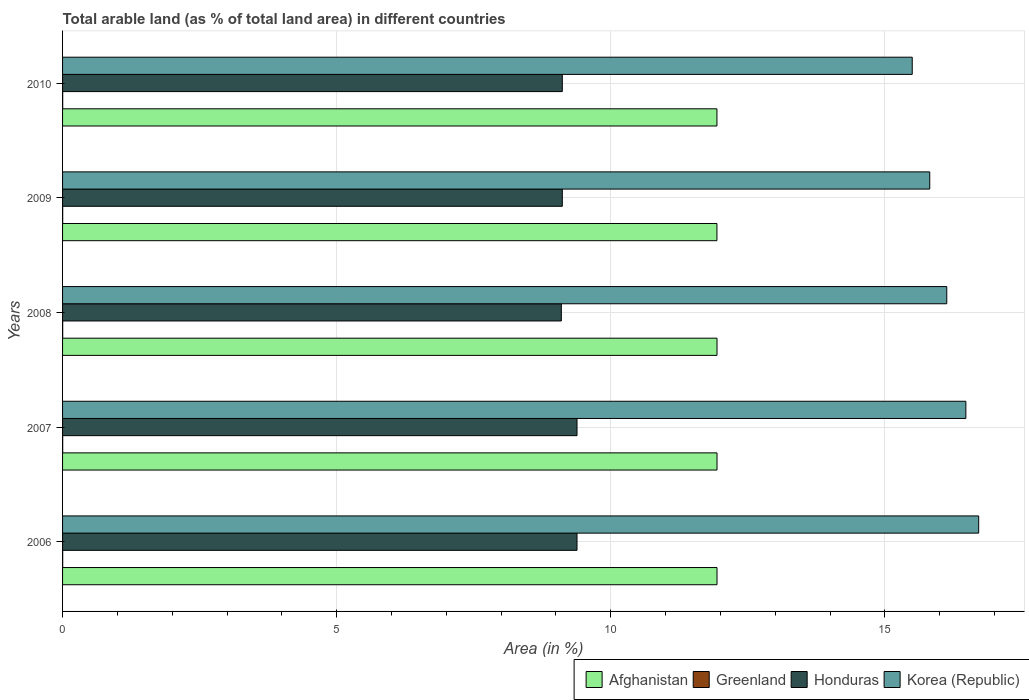How many groups of bars are there?
Give a very brief answer. 5. Are the number of bars on each tick of the Y-axis equal?
Make the answer very short. Yes. How many bars are there on the 2nd tick from the top?
Provide a succinct answer. 4. How many bars are there on the 5th tick from the bottom?
Make the answer very short. 4. What is the label of the 4th group of bars from the top?
Your answer should be compact. 2007. What is the percentage of arable land in Honduras in 2008?
Your answer should be compact. 9.1. Across all years, what is the maximum percentage of arable land in Korea (Republic)?
Make the answer very short. 16.71. Across all years, what is the minimum percentage of arable land in Korea (Republic)?
Ensure brevity in your answer.  15.5. In which year was the percentage of arable land in Honduras minimum?
Ensure brevity in your answer.  2008. What is the total percentage of arable land in Greenland in the graph?
Keep it short and to the point. 0.01. What is the difference between the percentage of arable land in Greenland in 2006 and that in 2007?
Provide a short and direct response. 0. What is the difference between the percentage of arable land in Korea (Republic) in 2006 and the percentage of arable land in Honduras in 2010?
Provide a short and direct response. 7.6. What is the average percentage of arable land in Korea (Republic) per year?
Provide a succinct answer. 16.13. In the year 2008, what is the difference between the percentage of arable land in Honduras and percentage of arable land in Afghanistan?
Your answer should be compact. -2.84. What is the ratio of the percentage of arable land in Korea (Republic) in 2006 to that in 2008?
Make the answer very short. 1.04. Is the percentage of arable land in Korea (Republic) in 2008 less than that in 2010?
Ensure brevity in your answer.  No. What is the difference between the highest and the lowest percentage of arable land in Greenland?
Offer a terse response. 0. Is it the case that in every year, the sum of the percentage of arable land in Afghanistan and percentage of arable land in Greenland is greater than the sum of percentage of arable land in Korea (Republic) and percentage of arable land in Honduras?
Give a very brief answer. No. What does the 3rd bar from the top in 2010 represents?
Give a very brief answer. Greenland. How many bars are there?
Keep it short and to the point. 20. Are all the bars in the graph horizontal?
Ensure brevity in your answer.  Yes. How many years are there in the graph?
Provide a short and direct response. 5. Where does the legend appear in the graph?
Your answer should be very brief. Bottom right. How many legend labels are there?
Your answer should be very brief. 4. What is the title of the graph?
Give a very brief answer. Total arable land (as % of total land area) in different countries. Does "Fiji" appear as one of the legend labels in the graph?
Provide a succinct answer. No. What is the label or title of the X-axis?
Give a very brief answer. Area (in %). What is the Area (in %) of Afghanistan in 2006?
Your response must be concise. 11.94. What is the Area (in %) of Greenland in 2006?
Your response must be concise. 0. What is the Area (in %) of Honduras in 2006?
Keep it short and to the point. 9.38. What is the Area (in %) in Korea (Republic) in 2006?
Give a very brief answer. 16.71. What is the Area (in %) of Afghanistan in 2007?
Your answer should be very brief. 11.94. What is the Area (in %) of Greenland in 2007?
Keep it short and to the point. 0. What is the Area (in %) of Honduras in 2007?
Keep it short and to the point. 9.38. What is the Area (in %) of Korea (Republic) in 2007?
Your answer should be very brief. 16.48. What is the Area (in %) in Afghanistan in 2008?
Your answer should be very brief. 11.94. What is the Area (in %) of Greenland in 2008?
Provide a short and direct response. 0. What is the Area (in %) in Honduras in 2008?
Keep it short and to the point. 9.1. What is the Area (in %) in Korea (Republic) in 2008?
Give a very brief answer. 16.13. What is the Area (in %) in Afghanistan in 2009?
Your response must be concise. 11.94. What is the Area (in %) in Greenland in 2009?
Provide a short and direct response. 0. What is the Area (in %) in Honduras in 2009?
Make the answer very short. 9.12. What is the Area (in %) of Korea (Republic) in 2009?
Provide a succinct answer. 15.82. What is the Area (in %) of Afghanistan in 2010?
Provide a succinct answer. 11.94. What is the Area (in %) of Greenland in 2010?
Your response must be concise. 0. What is the Area (in %) of Honduras in 2010?
Make the answer very short. 9.12. What is the Area (in %) in Korea (Republic) in 2010?
Keep it short and to the point. 15.5. Across all years, what is the maximum Area (in %) of Afghanistan?
Keep it short and to the point. 11.94. Across all years, what is the maximum Area (in %) in Greenland?
Give a very brief answer. 0. Across all years, what is the maximum Area (in %) of Honduras?
Make the answer very short. 9.38. Across all years, what is the maximum Area (in %) of Korea (Republic)?
Ensure brevity in your answer.  16.71. Across all years, what is the minimum Area (in %) of Afghanistan?
Ensure brevity in your answer.  11.94. Across all years, what is the minimum Area (in %) in Greenland?
Give a very brief answer. 0. Across all years, what is the minimum Area (in %) of Honduras?
Your answer should be very brief. 9.1. Across all years, what is the minimum Area (in %) of Korea (Republic)?
Your response must be concise. 15.5. What is the total Area (in %) of Afghanistan in the graph?
Offer a very short reply. 59.69. What is the total Area (in %) of Greenland in the graph?
Offer a terse response. 0.01. What is the total Area (in %) of Honduras in the graph?
Provide a short and direct response. 46.1. What is the total Area (in %) in Korea (Republic) in the graph?
Keep it short and to the point. 80.64. What is the difference between the Area (in %) of Greenland in 2006 and that in 2007?
Offer a terse response. 0. What is the difference between the Area (in %) of Korea (Republic) in 2006 and that in 2007?
Offer a very short reply. 0.23. What is the difference between the Area (in %) in Afghanistan in 2006 and that in 2008?
Your answer should be very brief. 0. What is the difference between the Area (in %) of Honduras in 2006 and that in 2008?
Make the answer very short. 0.29. What is the difference between the Area (in %) in Korea (Republic) in 2006 and that in 2008?
Offer a very short reply. 0.58. What is the difference between the Area (in %) of Afghanistan in 2006 and that in 2009?
Your answer should be compact. 0. What is the difference between the Area (in %) of Greenland in 2006 and that in 2009?
Your answer should be compact. 0. What is the difference between the Area (in %) in Honduras in 2006 and that in 2009?
Ensure brevity in your answer.  0.27. What is the difference between the Area (in %) of Korea (Republic) in 2006 and that in 2009?
Your response must be concise. 0.89. What is the difference between the Area (in %) in Afghanistan in 2006 and that in 2010?
Your response must be concise. 0. What is the difference between the Area (in %) in Honduras in 2006 and that in 2010?
Ensure brevity in your answer.  0.27. What is the difference between the Area (in %) in Korea (Republic) in 2006 and that in 2010?
Give a very brief answer. 1.21. What is the difference between the Area (in %) of Greenland in 2007 and that in 2008?
Your response must be concise. 0. What is the difference between the Area (in %) in Honduras in 2007 and that in 2008?
Provide a short and direct response. 0.29. What is the difference between the Area (in %) in Korea (Republic) in 2007 and that in 2008?
Provide a short and direct response. 0.35. What is the difference between the Area (in %) in Afghanistan in 2007 and that in 2009?
Provide a short and direct response. 0. What is the difference between the Area (in %) in Honduras in 2007 and that in 2009?
Make the answer very short. 0.27. What is the difference between the Area (in %) in Korea (Republic) in 2007 and that in 2009?
Offer a very short reply. 0.66. What is the difference between the Area (in %) in Afghanistan in 2007 and that in 2010?
Keep it short and to the point. 0. What is the difference between the Area (in %) of Greenland in 2007 and that in 2010?
Ensure brevity in your answer.  0. What is the difference between the Area (in %) of Honduras in 2007 and that in 2010?
Offer a terse response. 0.27. What is the difference between the Area (in %) of Korea (Republic) in 2007 and that in 2010?
Offer a terse response. 0.98. What is the difference between the Area (in %) in Afghanistan in 2008 and that in 2009?
Provide a short and direct response. 0. What is the difference between the Area (in %) in Greenland in 2008 and that in 2009?
Make the answer very short. 0. What is the difference between the Area (in %) of Honduras in 2008 and that in 2009?
Provide a succinct answer. -0.02. What is the difference between the Area (in %) in Korea (Republic) in 2008 and that in 2009?
Provide a short and direct response. 0.31. What is the difference between the Area (in %) of Afghanistan in 2008 and that in 2010?
Give a very brief answer. 0. What is the difference between the Area (in %) of Honduras in 2008 and that in 2010?
Your response must be concise. -0.02. What is the difference between the Area (in %) of Korea (Republic) in 2008 and that in 2010?
Provide a short and direct response. 0.63. What is the difference between the Area (in %) in Korea (Republic) in 2009 and that in 2010?
Make the answer very short. 0.32. What is the difference between the Area (in %) of Afghanistan in 2006 and the Area (in %) of Greenland in 2007?
Offer a very short reply. 11.94. What is the difference between the Area (in %) of Afghanistan in 2006 and the Area (in %) of Honduras in 2007?
Offer a very short reply. 2.55. What is the difference between the Area (in %) in Afghanistan in 2006 and the Area (in %) in Korea (Republic) in 2007?
Provide a short and direct response. -4.54. What is the difference between the Area (in %) in Greenland in 2006 and the Area (in %) in Honduras in 2007?
Your response must be concise. -9.38. What is the difference between the Area (in %) in Greenland in 2006 and the Area (in %) in Korea (Republic) in 2007?
Ensure brevity in your answer.  -16.48. What is the difference between the Area (in %) of Honduras in 2006 and the Area (in %) of Korea (Republic) in 2007?
Offer a very short reply. -7.09. What is the difference between the Area (in %) of Afghanistan in 2006 and the Area (in %) of Greenland in 2008?
Provide a succinct answer. 11.94. What is the difference between the Area (in %) of Afghanistan in 2006 and the Area (in %) of Honduras in 2008?
Your answer should be very brief. 2.84. What is the difference between the Area (in %) of Afghanistan in 2006 and the Area (in %) of Korea (Republic) in 2008?
Offer a terse response. -4.19. What is the difference between the Area (in %) in Greenland in 2006 and the Area (in %) in Honduras in 2008?
Ensure brevity in your answer.  -9.1. What is the difference between the Area (in %) in Greenland in 2006 and the Area (in %) in Korea (Republic) in 2008?
Provide a short and direct response. -16.13. What is the difference between the Area (in %) of Honduras in 2006 and the Area (in %) of Korea (Republic) in 2008?
Your answer should be compact. -6.74. What is the difference between the Area (in %) in Afghanistan in 2006 and the Area (in %) in Greenland in 2009?
Your response must be concise. 11.94. What is the difference between the Area (in %) in Afghanistan in 2006 and the Area (in %) in Honduras in 2009?
Give a very brief answer. 2.82. What is the difference between the Area (in %) in Afghanistan in 2006 and the Area (in %) in Korea (Republic) in 2009?
Provide a succinct answer. -3.88. What is the difference between the Area (in %) of Greenland in 2006 and the Area (in %) of Honduras in 2009?
Ensure brevity in your answer.  -9.11. What is the difference between the Area (in %) of Greenland in 2006 and the Area (in %) of Korea (Republic) in 2009?
Your response must be concise. -15.82. What is the difference between the Area (in %) in Honduras in 2006 and the Area (in %) in Korea (Republic) in 2009?
Keep it short and to the point. -6.43. What is the difference between the Area (in %) in Afghanistan in 2006 and the Area (in %) in Greenland in 2010?
Make the answer very short. 11.94. What is the difference between the Area (in %) in Afghanistan in 2006 and the Area (in %) in Honduras in 2010?
Give a very brief answer. 2.82. What is the difference between the Area (in %) in Afghanistan in 2006 and the Area (in %) in Korea (Republic) in 2010?
Offer a very short reply. -3.56. What is the difference between the Area (in %) in Greenland in 2006 and the Area (in %) in Honduras in 2010?
Make the answer very short. -9.11. What is the difference between the Area (in %) in Greenland in 2006 and the Area (in %) in Korea (Republic) in 2010?
Ensure brevity in your answer.  -15.5. What is the difference between the Area (in %) in Honduras in 2006 and the Area (in %) in Korea (Republic) in 2010?
Make the answer very short. -6.12. What is the difference between the Area (in %) in Afghanistan in 2007 and the Area (in %) in Greenland in 2008?
Offer a terse response. 11.94. What is the difference between the Area (in %) of Afghanistan in 2007 and the Area (in %) of Honduras in 2008?
Provide a short and direct response. 2.84. What is the difference between the Area (in %) in Afghanistan in 2007 and the Area (in %) in Korea (Republic) in 2008?
Offer a very short reply. -4.19. What is the difference between the Area (in %) of Greenland in 2007 and the Area (in %) of Honduras in 2008?
Your response must be concise. -9.1. What is the difference between the Area (in %) in Greenland in 2007 and the Area (in %) in Korea (Republic) in 2008?
Ensure brevity in your answer.  -16.13. What is the difference between the Area (in %) of Honduras in 2007 and the Area (in %) of Korea (Republic) in 2008?
Keep it short and to the point. -6.74. What is the difference between the Area (in %) in Afghanistan in 2007 and the Area (in %) in Greenland in 2009?
Ensure brevity in your answer.  11.94. What is the difference between the Area (in %) of Afghanistan in 2007 and the Area (in %) of Honduras in 2009?
Your answer should be compact. 2.82. What is the difference between the Area (in %) of Afghanistan in 2007 and the Area (in %) of Korea (Republic) in 2009?
Offer a terse response. -3.88. What is the difference between the Area (in %) in Greenland in 2007 and the Area (in %) in Honduras in 2009?
Ensure brevity in your answer.  -9.11. What is the difference between the Area (in %) of Greenland in 2007 and the Area (in %) of Korea (Republic) in 2009?
Ensure brevity in your answer.  -15.82. What is the difference between the Area (in %) of Honduras in 2007 and the Area (in %) of Korea (Republic) in 2009?
Give a very brief answer. -6.43. What is the difference between the Area (in %) of Afghanistan in 2007 and the Area (in %) of Greenland in 2010?
Provide a succinct answer. 11.94. What is the difference between the Area (in %) in Afghanistan in 2007 and the Area (in %) in Honduras in 2010?
Give a very brief answer. 2.82. What is the difference between the Area (in %) of Afghanistan in 2007 and the Area (in %) of Korea (Republic) in 2010?
Keep it short and to the point. -3.56. What is the difference between the Area (in %) in Greenland in 2007 and the Area (in %) in Honduras in 2010?
Ensure brevity in your answer.  -9.11. What is the difference between the Area (in %) in Greenland in 2007 and the Area (in %) in Korea (Republic) in 2010?
Your answer should be compact. -15.5. What is the difference between the Area (in %) in Honduras in 2007 and the Area (in %) in Korea (Republic) in 2010?
Offer a very short reply. -6.12. What is the difference between the Area (in %) of Afghanistan in 2008 and the Area (in %) of Greenland in 2009?
Your response must be concise. 11.94. What is the difference between the Area (in %) in Afghanistan in 2008 and the Area (in %) in Honduras in 2009?
Provide a succinct answer. 2.82. What is the difference between the Area (in %) in Afghanistan in 2008 and the Area (in %) in Korea (Republic) in 2009?
Offer a very short reply. -3.88. What is the difference between the Area (in %) in Greenland in 2008 and the Area (in %) in Honduras in 2009?
Give a very brief answer. -9.11. What is the difference between the Area (in %) in Greenland in 2008 and the Area (in %) in Korea (Republic) in 2009?
Offer a terse response. -15.82. What is the difference between the Area (in %) of Honduras in 2008 and the Area (in %) of Korea (Republic) in 2009?
Offer a terse response. -6.72. What is the difference between the Area (in %) in Afghanistan in 2008 and the Area (in %) in Greenland in 2010?
Your response must be concise. 11.94. What is the difference between the Area (in %) in Afghanistan in 2008 and the Area (in %) in Honduras in 2010?
Make the answer very short. 2.82. What is the difference between the Area (in %) of Afghanistan in 2008 and the Area (in %) of Korea (Republic) in 2010?
Offer a terse response. -3.56. What is the difference between the Area (in %) in Greenland in 2008 and the Area (in %) in Honduras in 2010?
Offer a terse response. -9.11. What is the difference between the Area (in %) of Greenland in 2008 and the Area (in %) of Korea (Republic) in 2010?
Offer a very short reply. -15.5. What is the difference between the Area (in %) of Honduras in 2008 and the Area (in %) of Korea (Republic) in 2010?
Give a very brief answer. -6.4. What is the difference between the Area (in %) in Afghanistan in 2009 and the Area (in %) in Greenland in 2010?
Offer a very short reply. 11.93. What is the difference between the Area (in %) of Afghanistan in 2009 and the Area (in %) of Honduras in 2010?
Ensure brevity in your answer.  2.82. What is the difference between the Area (in %) of Afghanistan in 2009 and the Area (in %) of Korea (Republic) in 2010?
Ensure brevity in your answer.  -3.56. What is the difference between the Area (in %) of Greenland in 2009 and the Area (in %) of Honduras in 2010?
Your answer should be compact. -9.11. What is the difference between the Area (in %) in Greenland in 2009 and the Area (in %) in Korea (Republic) in 2010?
Offer a very short reply. -15.5. What is the difference between the Area (in %) of Honduras in 2009 and the Area (in %) of Korea (Republic) in 2010?
Provide a succinct answer. -6.38. What is the average Area (in %) of Afghanistan per year?
Your answer should be compact. 11.94. What is the average Area (in %) of Greenland per year?
Provide a succinct answer. 0. What is the average Area (in %) in Honduras per year?
Give a very brief answer. 9.22. What is the average Area (in %) in Korea (Republic) per year?
Give a very brief answer. 16.13. In the year 2006, what is the difference between the Area (in %) in Afghanistan and Area (in %) in Greenland?
Your response must be concise. 11.94. In the year 2006, what is the difference between the Area (in %) in Afghanistan and Area (in %) in Honduras?
Offer a terse response. 2.55. In the year 2006, what is the difference between the Area (in %) in Afghanistan and Area (in %) in Korea (Republic)?
Keep it short and to the point. -4.77. In the year 2006, what is the difference between the Area (in %) in Greenland and Area (in %) in Honduras?
Make the answer very short. -9.38. In the year 2006, what is the difference between the Area (in %) of Greenland and Area (in %) of Korea (Republic)?
Your answer should be very brief. -16.71. In the year 2006, what is the difference between the Area (in %) in Honduras and Area (in %) in Korea (Republic)?
Give a very brief answer. -7.33. In the year 2007, what is the difference between the Area (in %) of Afghanistan and Area (in %) of Greenland?
Your answer should be very brief. 11.94. In the year 2007, what is the difference between the Area (in %) in Afghanistan and Area (in %) in Honduras?
Give a very brief answer. 2.55. In the year 2007, what is the difference between the Area (in %) in Afghanistan and Area (in %) in Korea (Republic)?
Offer a terse response. -4.54. In the year 2007, what is the difference between the Area (in %) of Greenland and Area (in %) of Honduras?
Keep it short and to the point. -9.38. In the year 2007, what is the difference between the Area (in %) of Greenland and Area (in %) of Korea (Republic)?
Offer a very short reply. -16.48. In the year 2007, what is the difference between the Area (in %) of Honduras and Area (in %) of Korea (Republic)?
Your answer should be compact. -7.09. In the year 2008, what is the difference between the Area (in %) of Afghanistan and Area (in %) of Greenland?
Offer a very short reply. 11.94. In the year 2008, what is the difference between the Area (in %) of Afghanistan and Area (in %) of Honduras?
Ensure brevity in your answer.  2.84. In the year 2008, what is the difference between the Area (in %) of Afghanistan and Area (in %) of Korea (Republic)?
Ensure brevity in your answer.  -4.19. In the year 2008, what is the difference between the Area (in %) of Greenland and Area (in %) of Honduras?
Provide a succinct answer. -9.1. In the year 2008, what is the difference between the Area (in %) in Greenland and Area (in %) in Korea (Republic)?
Ensure brevity in your answer.  -16.13. In the year 2008, what is the difference between the Area (in %) of Honduras and Area (in %) of Korea (Republic)?
Ensure brevity in your answer.  -7.03. In the year 2009, what is the difference between the Area (in %) in Afghanistan and Area (in %) in Greenland?
Your answer should be very brief. 11.93. In the year 2009, what is the difference between the Area (in %) in Afghanistan and Area (in %) in Honduras?
Provide a succinct answer. 2.82. In the year 2009, what is the difference between the Area (in %) of Afghanistan and Area (in %) of Korea (Republic)?
Offer a terse response. -3.88. In the year 2009, what is the difference between the Area (in %) in Greenland and Area (in %) in Honduras?
Ensure brevity in your answer.  -9.11. In the year 2009, what is the difference between the Area (in %) of Greenland and Area (in %) of Korea (Republic)?
Your answer should be compact. -15.82. In the year 2009, what is the difference between the Area (in %) in Honduras and Area (in %) in Korea (Republic)?
Your answer should be very brief. -6.7. In the year 2010, what is the difference between the Area (in %) in Afghanistan and Area (in %) in Greenland?
Your answer should be compact. 11.93. In the year 2010, what is the difference between the Area (in %) in Afghanistan and Area (in %) in Honduras?
Offer a very short reply. 2.82. In the year 2010, what is the difference between the Area (in %) in Afghanistan and Area (in %) in Korea (Republic)?
Your answer should be compact. -3.56. In the year 2010, what is the difference between the Area (in %) of Greenland and Area (in %) of Honduras?
Your answer should be compact. -9.11. In the year 2010, what is the difference between the Area (in %) of Greenland and Area (in %) of Korea (Republic)?
Provide a short and direct response. -15.5. In the year 2010, what is the difference between the Area (in %) of Honduras and Area (in %) of Korea (Republic)?
Provide a short and direct response. -6.38. What is the ratio of the Area (in %) of Greenland in 2006 to that in 2007?
Make the answer very short. 1. What is the ratio of the Area (in %) in Honduras in 2006 to that in 2007?
Your answer should be very brief. 1. What is the ratio of the Area (in %) of Korea (Republic) in 2006 to that in 2007?
Give a very brief answer. 1.01. What is the ratio of the Area (in %) of Afghanistan in 2006 to that in 2008?
Provide a short and direct response. 1. What is the ratio of the Area (in %) in Honduras in 2006 to that in 2008?
Ensure brevity in your answer.  1.03. What is the ratio of the Area (in %) in Korea (Republic) in 2006 to that in 2008?
Provide a succinct answer. 1.04. What is the ratio of the Area (in %) in Afghanistan in 2006 to that in 2009?
Your answer should be compact. 1. What is the ratio of the Area (in %) of Greenland in 2006 to that in 2009?
Keep it short and to the point. 1. What is the ratio of the Area (in %) of Honduras in 2006 to that in 2009?
Ensure brevity in your answer.  1.03. What is the ratio of the Area (in %) in Korea (Republic) in 2006 to that in 2009?
Make the answer very short. 1.06. What is the ratio of the Area (in %) in Greenland in 2006 to that in 2010?
Your response must be concise. 1. What is the ratio of the Area (in %) of Honduras in 2006 to that in 2010?
Offer a terse response. 1.03. What is the ratio of the Area (in %) in Korea (Republic) in 2006 to that in 2010?
Keep it short and to the point. 1.08. What is the ratio of the Area (in %) in Honduras in 2007 to that in 2008?
Offer a very short reply. 1.03. What is the ratio of the Area (in %) of Korea (Republic) in 2007 to that in 2008?
Your answer should be very brief. 1.02. What is the ratio of the Area (in %) in Afghanistan in 2007 to that in 2009?
Give a very brief answer. 1. What is the ratio of the Area (in %) in Greenland in 2007 to that in 2009?
Your response must be concise. 1. What is the ratio of the Area (in %) in Honduras in 2007 to that in 2009?
Provide a succinct answer. 1.03. What is the ratio of the Area (in %) of Korea (Republic) in 2007 to that in 2009?
Give a very brief answer. 1.04. What is the ratio of the Area (in %) of Afghanistan in 2007 to that in 2010?
Provide a succinct answer. 1. What is the ratio of the Area (in %) of Greenland in 2007 to that in 2010?
Ensure brevity in your answer.  1. What is the ratio of the Area (in %) of Honduras in 2007 to that in 2010?
Provide a short and direct response. 1.03. What is the ratio of the Area (in %) in Korea (Republic) in 2007 to that in 2010?
Your answer should be compact. 1.06. What is the ratio of the Area (in %) in Greenland in 2008 to that in 2009?
Ensure brevity in your answer.  1. What is the ratio of the Area (in %) of Korea (Republic) in 2008 to that in 2009?
Provide a short and direct response. 1.02. What is the ratio of the Area (in %) of Honduras in 2008 to that in 2010?
Your response must be concise. 1. What is the ratio of the Area (in %) in Korea (Republic) in 2008 to that in 2010?
Your answer should be very brief. 1.04. What is the ratio of the Area (in %) of Korea (Republic) in 2009 to that in 2010?
Provide a succinct answer. 1.02. What is the difference between the highest and the second highest Area (in %) of Afghanistan?
Ensure brevity in your answer.  0. What is the difference between the highest and the second highest Area (in %) in Honduras?
Your answer should be very brief. 0. What is the difference between the highest and the second highest Area (in %) of Korea (Republic)?
Provide a short and direct response. 0.23. What is the difference between the highest and the lowest Area (in %) in Afghanistan?
Provide a short and direct response. 0. What is the difference between the highest and the lowest Area (in %) in Honduras?
Your answer should be compact. 0.29. What is the difference between the highest and the lowest Area (in %) in Korea (Republic)?
Ensure brevity in your answer.  1.21. 